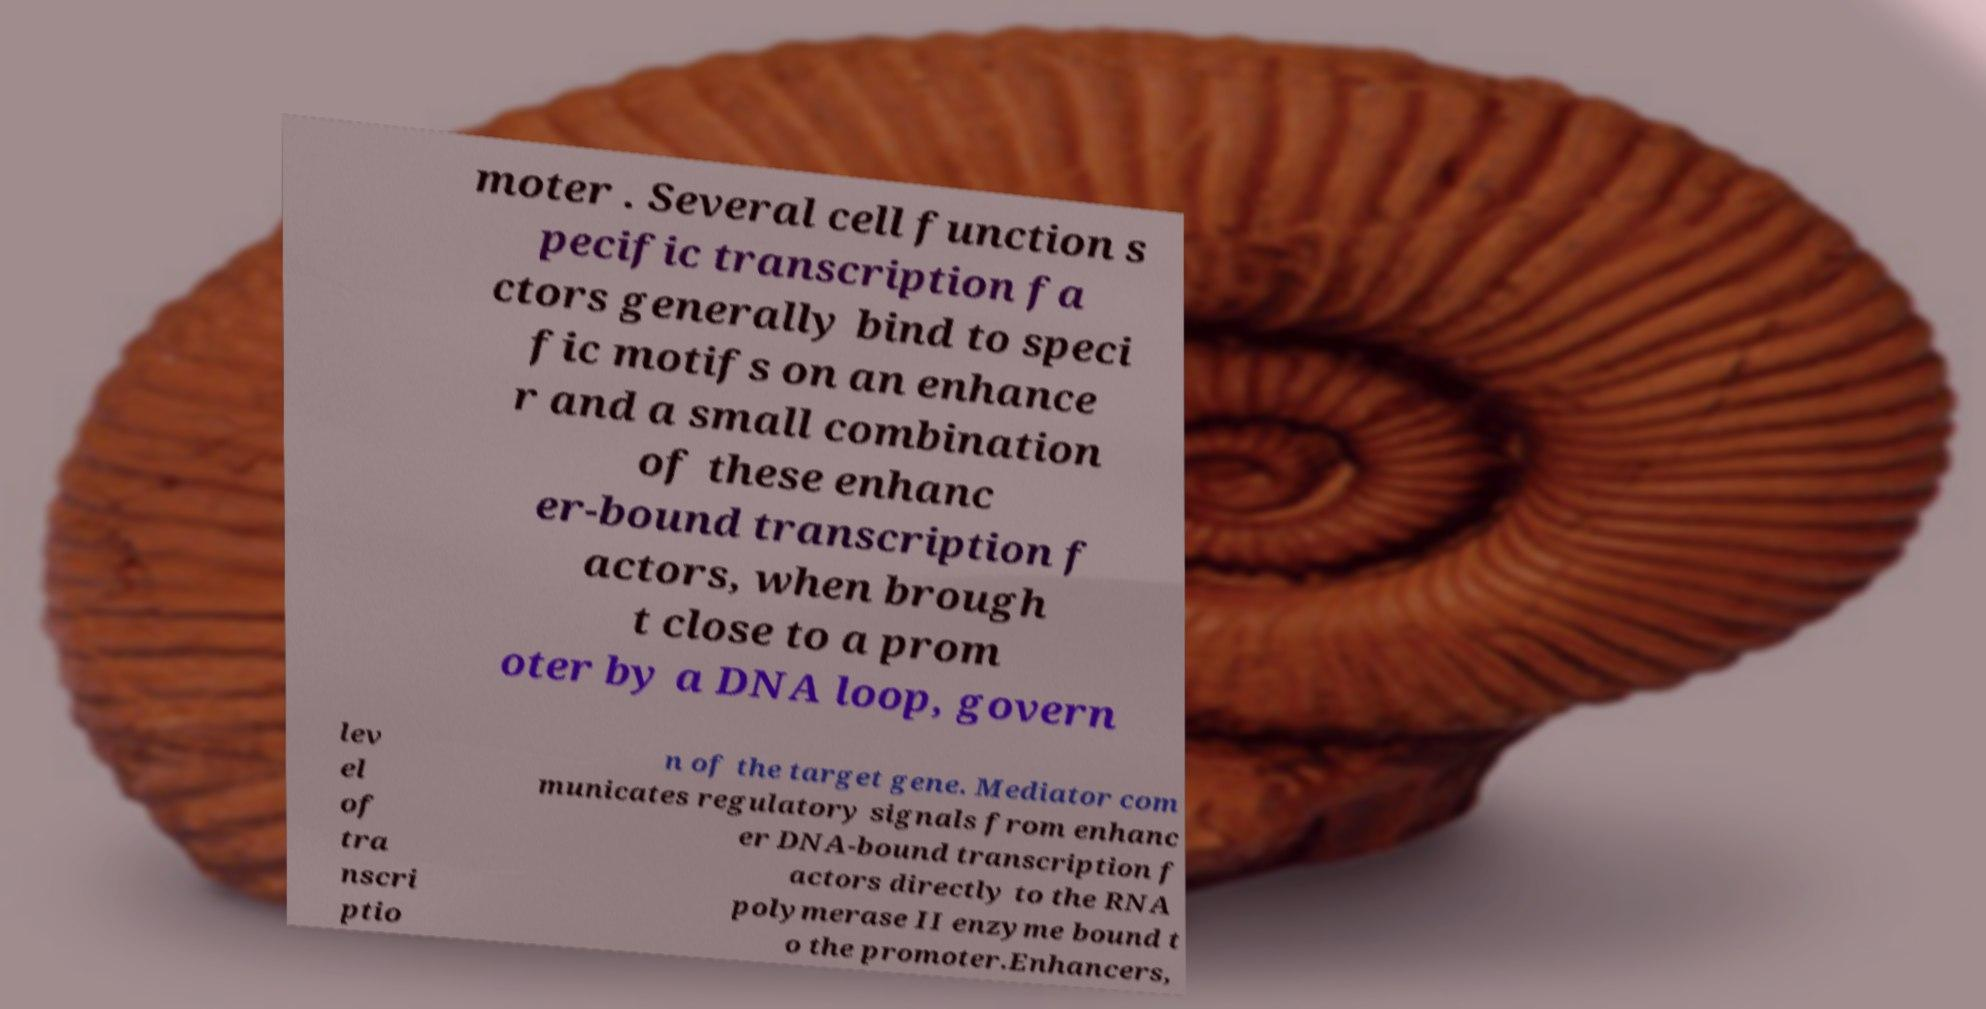I need the written content from this picture converted into text. Can you do that? moter . Several cell function s pecific transcription fa ctors generally bind to speci fic motifs on an enhance r and a small combination of these enhanc er-bound transcription f actors, when brough t close to a prom oter by a DNA loop, govern lev el of tra nscri ptio n of the target gene. Mediator com municates regulatory signals from enhanc er DNA-bound transcription f actors directly to the RNA polymerase II enzyme bound t o the promoter.Enhancers, 